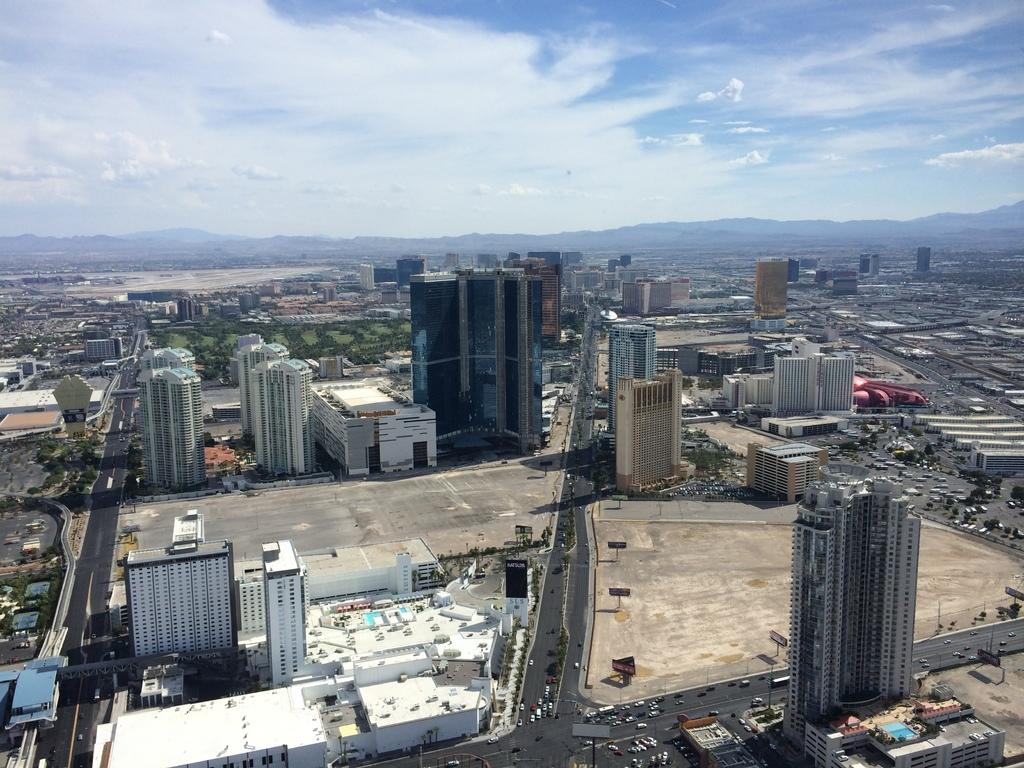What type of view is shown in the image? The image is an aerial view. What structures can be seen in the image? There are buildings, towers, and trees in the image. Are there any vehicles visible in the image? Yes, there are vehicles on the road in the image. What is visible at the top of the image? The sky is visible at the top of the image. Can you see a zebra kicking a soccer ball in the image? No, there is no zebra or soccer ball present in the image. Is there a pig visible in the image? No, there is no pig visible in the image. 